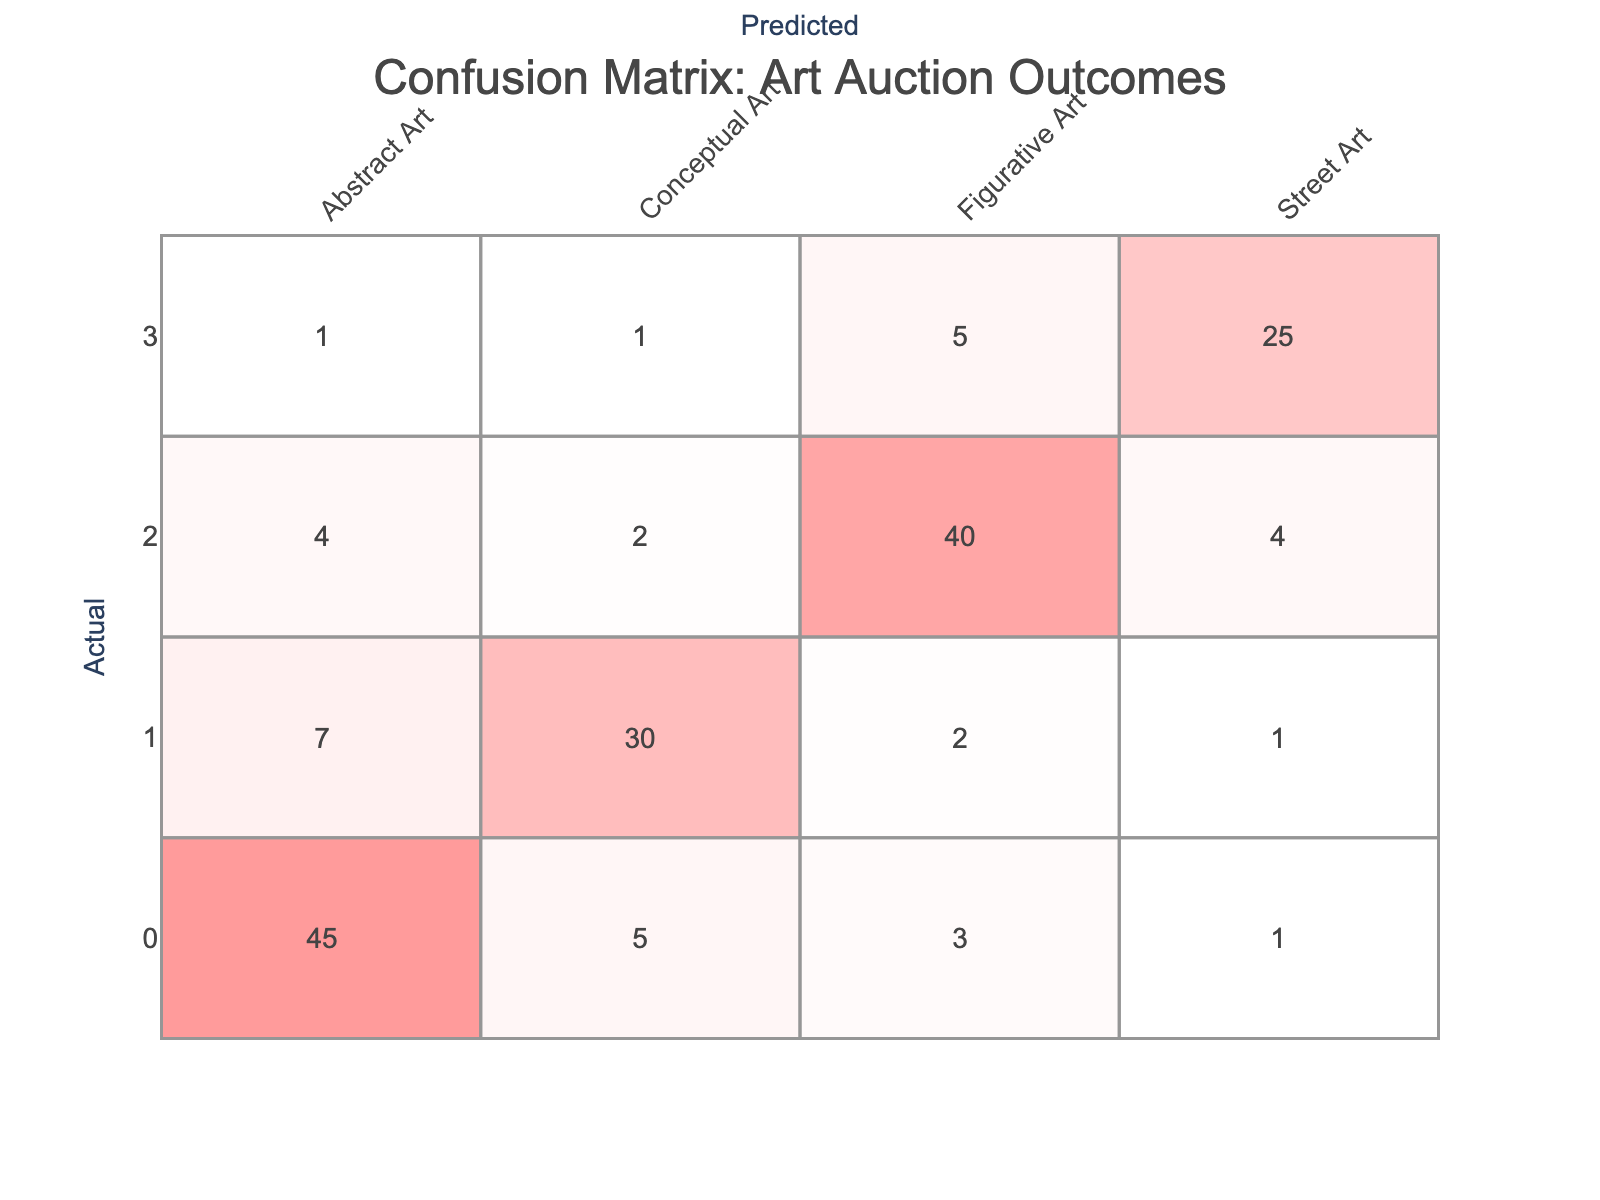What is the predicted count of Abstract Art that was actually Abstract Art? In the confusion matrix, we look at the row for Actual Abstract Art and the column for Predicted Abstract Art. The intersection shows a count of 45, indicating that this many pieces were correctly predicted as Abstract Art.
Answer: 45 What is the total number of Figurative Art artworks predicted? To find the total predicted Figurative Art artworks, we sum the values in the Figurative Art column: 3 (from Abstract Art) + 2 (from Conceptual Art) + 40 (from Figurative Art) + 5 (from Street Art) = 50.
Answer: 50 Is the predicted count of Street Art higher than the predicted count of Abstract Art? The predicted count for Street Art is 25 while the predicted count for Abstract Art is 45. Since 25 is less than 45, the statement is false.
Answer: No What is the total count of actual Conceptual Art artworks across all predictions? The total number of actual Conceptual Art artworks can be calculated by summing the values in the Conceptual Art row: 7 (predicted Abstract Art) + 30 (predicted Conceptual Art) + 2 (predicted Figurative Art) + 1 (predicted Street Art) = 40.
Answer: 40 What percentage of the predicted Figurative Art is correctly classified? The correct classification is from the Figurative Art row in the Figurative Art column (40), while the total predictions for Figurative Art is 50 (sum of the Figurative Art column). The percentage is (40/50)*100 = 80%.
Answer: 80% What is the ratio of actual Street Art classified accurately vs inaccurately? The actual Street Art correctly classified is 25 (in the Street Art row and column intersection), whereas the inaccurately classified are 1 (Abstract Art) + 1 (Conceptual Art) + 5 (Figurative Art) = 7. The ratio is 25:7.
Answer: 25:7 How many more artworks were predicted as Conceptual Art than as Street Art? The predicted count of Conceptual Art is 30, while the predicted count for Street Art is 25. The difference is 30 - 25 = 5, indicating 5 more were predicted as Conceptual Art.
Answer: 5 What is the accuracy of predicting Abstract Art? The accuracy for Abstract Art can be calculated by taking the correct predictions (45) divided by the total actual Abstract Art predictions (45 + 5 + 3 + 1 = 54). Therefore, accuracy is 45/54 = approximately 0.833, or 83.3%.
Answer: 83.3% 